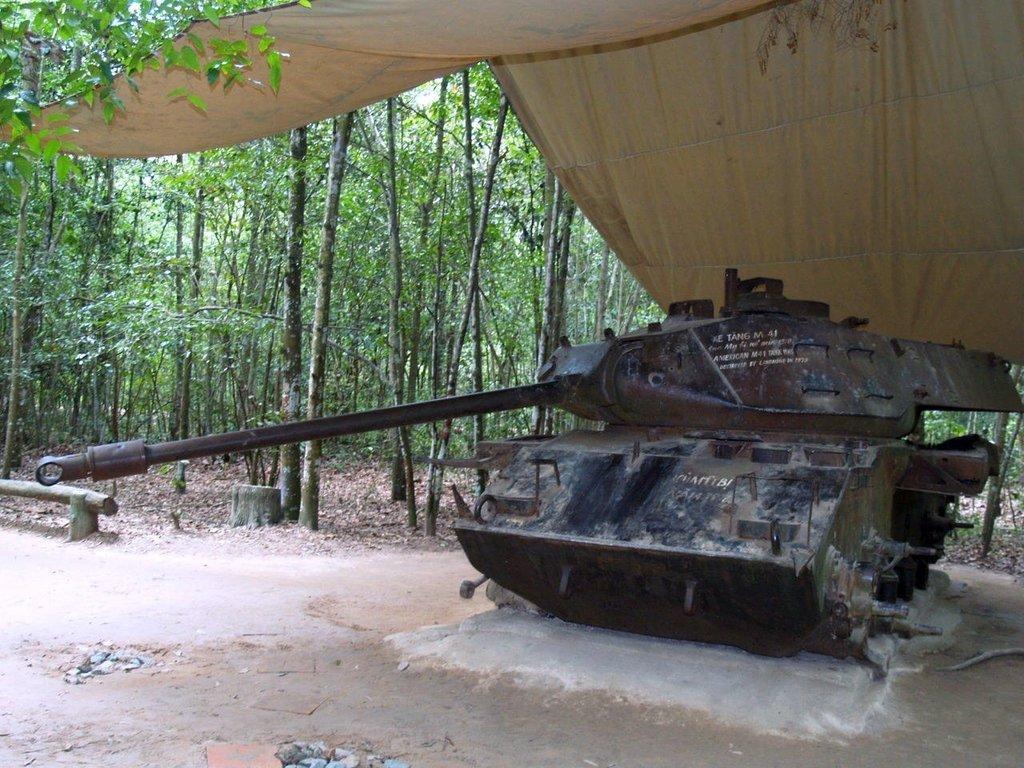Can you describe this image briefly? In this picture we can see a war tanker under the tent, in the background we can see trees. 